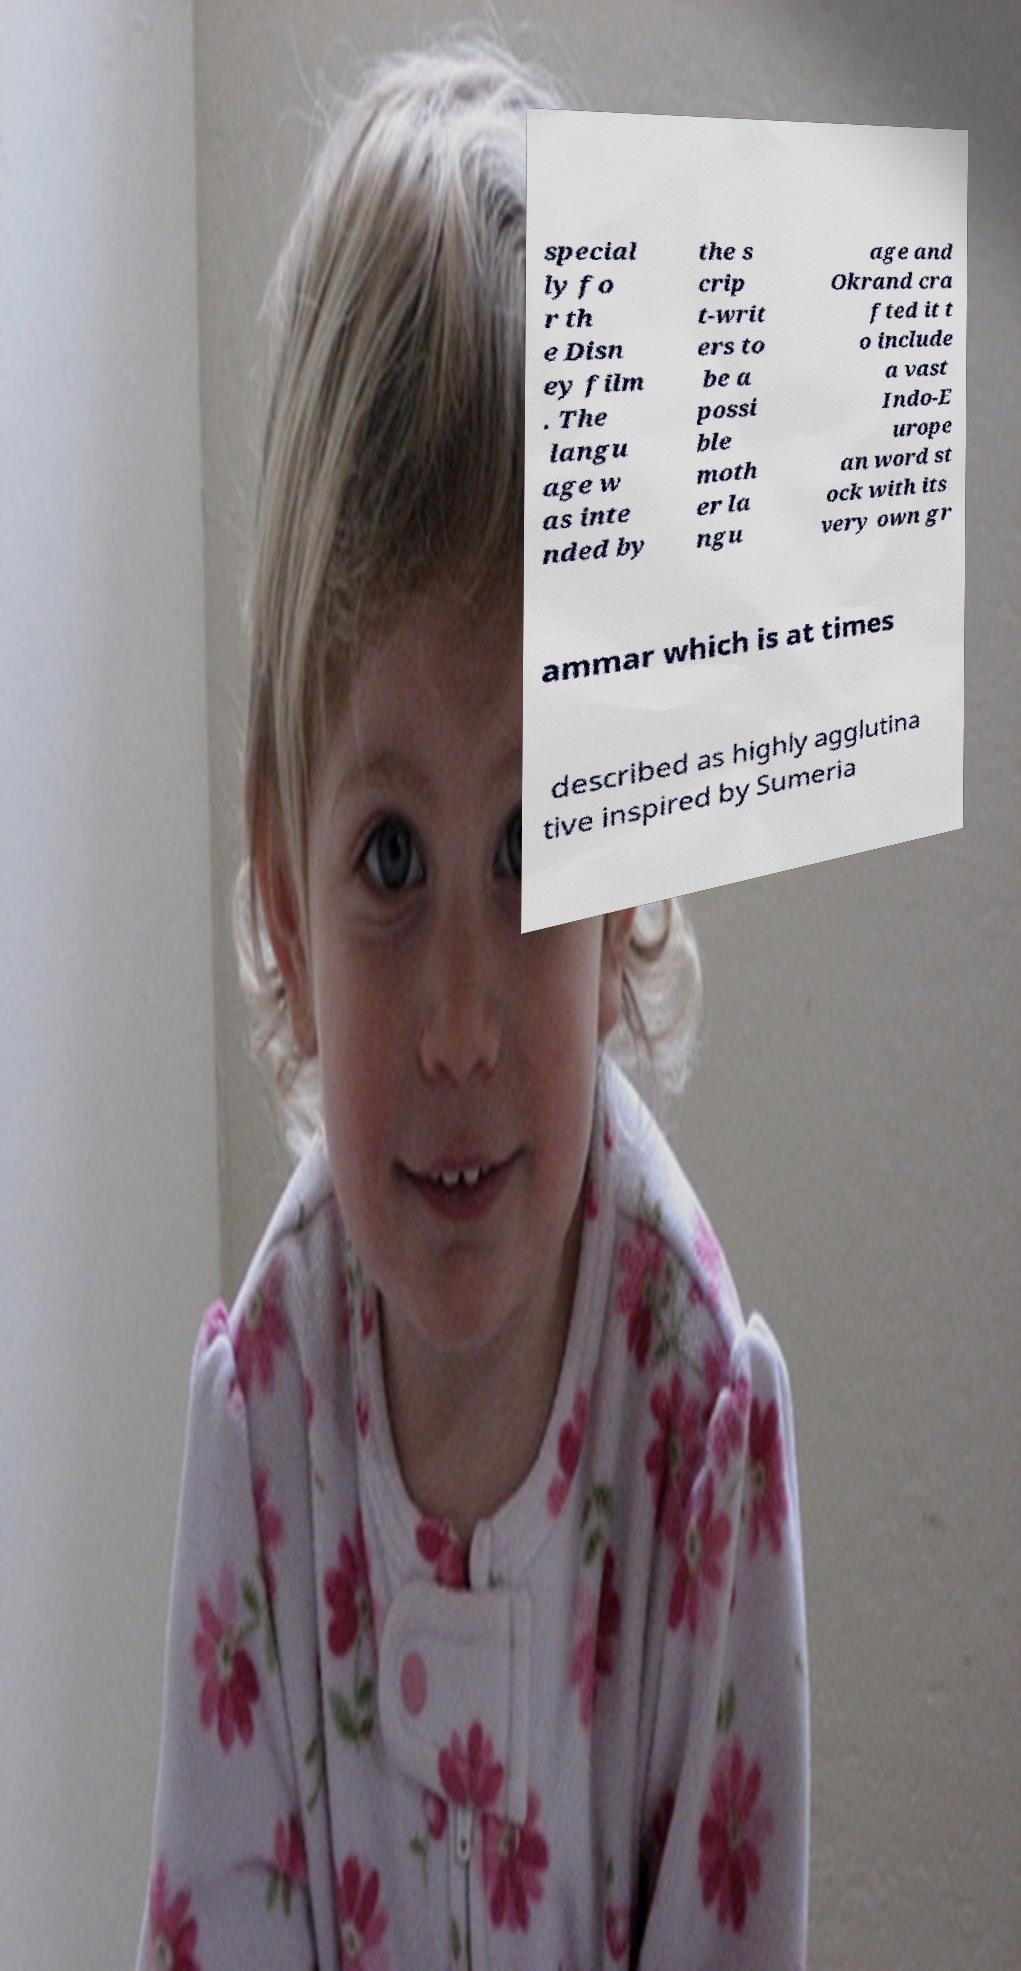What messages or text are displayed in this image? I need them in a readable, typed format. special ly fo r th e Disn ey film . The langu age w as inte nded by the s crip t-writ ers to be a possi ble moth er la ngu age and Okrand cra fted it t o include a vast Indo-E urope an word st ock with its very own gr ammar which is at times described as highly agglutina tive inspired by Sumeria 